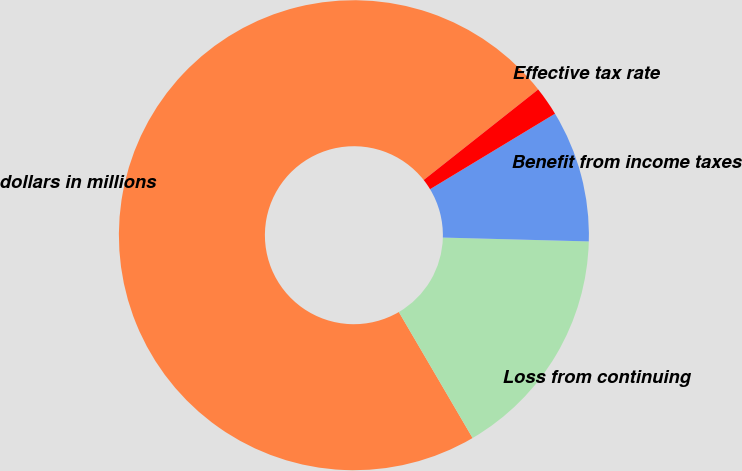Convert chart. <chart><loc_0><loc_0><loc_500><loc_500><pie_chart><fcel>dollars in millions<fcel>Loss from continuing<fcel>Benefit from income taxes<fcel>Effective tax rate<nl><fcel>72.78%<fcel>16.15%<fcel>9.07%<fcel>2.0%<nl></chart> 